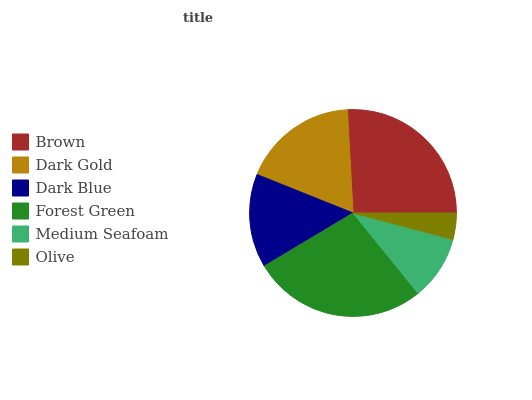Is Olive the minimum?
Answer yes or no. Yes. Is Forest Green the maximum?
Answer yes or no. Yes. Is Dark Gold the minimum?
Answer yes or no. No. Is Dark Gold the maximum?
Answer yes or no. No. Is Brown greater than Dark Gold?
Answer yes or no. Yes. Is Dark Gold less than Brown?
Answer yes or no. Yes. Is Dark Gold greater than Brown?
Answer yes or no. No. Is Brown less than Dark Gold?
Answer yes or no. No. Is Dark Gold the high median?
Answer yes or no. Yes. Is Dark Blue the low median?
Answer yes or no. Yes. Is Dark Blue the high median?
Answer yes or no. No. Is Brown the low median?
Answer yes or no. No. 